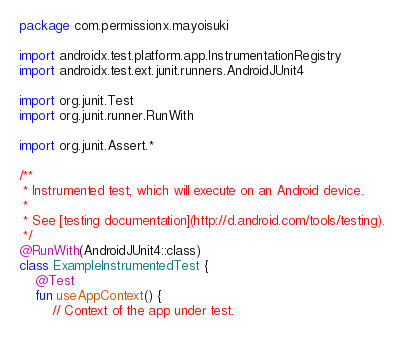Convert code to text. <code><loc_0><loc_0><loc_500><loc_500><_Kotlin_>package com.permissionx.mayoisuki

import androidx.test.platform.app.InstrumentationRegistry
import androidx.test.ext.junit.runners.AndroidJUnit4

import org.junit.Test
import org.junit.runner.RunWith

import org.junit.Assert.*

/**
 * Instrumented test, which will execute on an Android device.
 *
 * See [testing documentation](http://d.android.com/tools/testing).
 */
@RunWith(AndroidJUnit4::class)
class ExampleInstrumentedTest {
    @Test
    fun useAppContext() {
        // Context of the app under test.</code> 